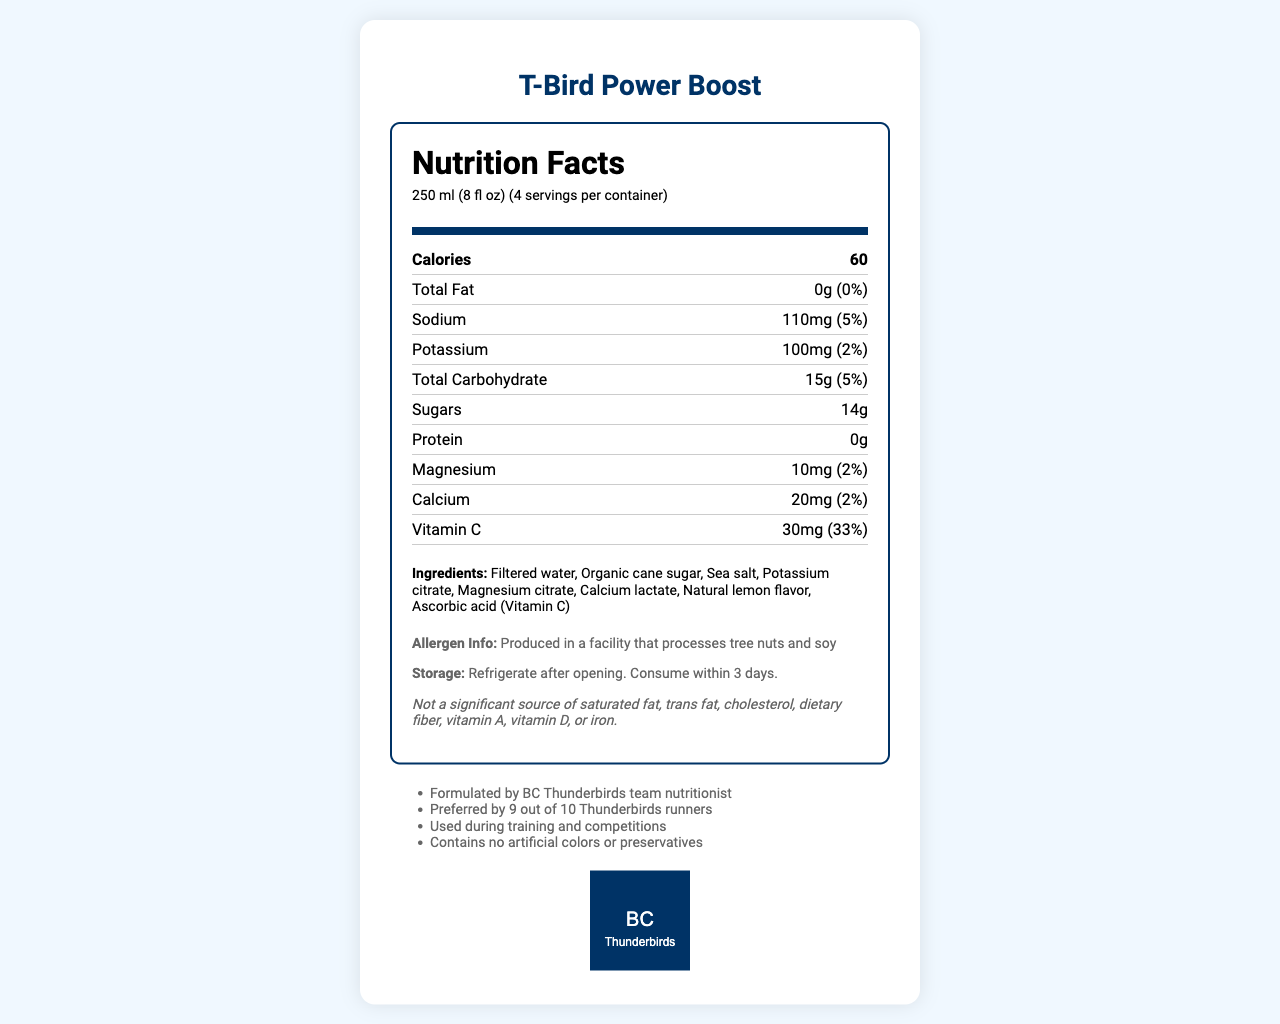what is the name of the product? The product name is clearly indicated at the top of the document.
Answer: T-Bird Power Boost what is the serving size of T-Bird Power Boost? The serving size is listed in the nutrition facts label, showing "250 ml (8 fl oz)".
Answer: 250 ml (8 fl oz) how many servings are in a container? The document specifies that there are 4 servings per container.
Answer: 4 how many calories are in one serving? The calories count per serving is listed as 60 in the nutrition facts section.
Answer: 60 what is the amount of total fat per serving? The total fat content per serving is 0 grams, as mentioned in the nutrition facts.
Answer: 0g what is the sodium content per serving? Sodium content per serving is listed as 110mg.
Answer: 110mg what percentage of the daily value of vitamin C does one serving provide? The daily value percentage of vitamin C per serving is given as 33%.
Answer: 33% how much sugar is in one serving of T-Bird Power Boost? The document states that there are 14 grams of sugars in one serving.
Answer: 14g which of the following ingredients is not listed in T-Bird Power Boost?
A. Sea salt  
B. Artificial colors  
C. Ascorbic acid The ingredients section lists "Sea salt" and "Ascorbic acid (Vitamin C)", but there are no artificial colors or preservatives.
Answer: B T-Bird Power Boost is mainly used for which purposes? (choose all that apply)
I. Training  
II. Competitions  
III. Weight loss The additional info states that it is used "during training and competitions", but weight loss is not mentioned.
Answer: I and II is T-Bird Power Boost produced in a facility that processes allergens? Yes, the allergen info indicates it is produced in a facility that processes tree nuts and soy.
Answer: Yes summarize the main points about T-Bird Power Boost This summary captures the main elements of the document, focusing on the product's purpose, use, nutritional facts, ingredients, and additional information.
Answer: T-Bird Power Boost is a homemade electrolyte drink preferred by the BC Thunderbirds women's cross country team. It's formulated by the team nutritionist, free from artificial colors and preservatives, and used during training and competitions. Each serving is 250 ml, providing 60 calories, 110 mg sodium, 100 mg potassium, and 14g of sugars, among other nutrients. The ingredients include filtered water, organic cane sugar, sea salt, and various citrates and lactates. what is the percentage of daily value for calcium per serving? The daily value percentage for calcium per serving is listed as 2%.
Answer: 2% what storage instruction is given for T-Bird Power Boost? The storage instructions specify to refrigerate after opening and consume within 3 days.
Answer: Refrigerate after opening. Consume within 3 days. what is the daily value percentage for magnesium per serving? The daily value percentage for magnesium per serving is listed as 2%.
Answer: 2% what is the primary source of sweetener in T-Bird Power Boost? The ingredient list states "Organic cane sugar" as the primary source of sweetener.
Answer: Organic cane sugar how many milligrams of calcium are in one serving? The amount of calcium per serving is indicated as 20 mg in the nutrition facts section.
Answer: 20mg where was T-Bird Power Boost formulated? The additional info mentions that it was formulated by the BC Thunderbirds team nutritionist.
Answer: BC Thunderbirds team nutritionist determine the amount of dietary fiber in one serving The disclaimer section explicitly states that the product is "Not a significant source of dietary fiber", but exact amounts are not provided.
Answer: Not enough information 